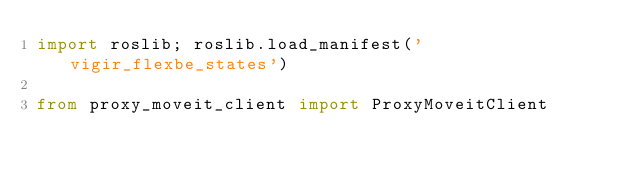Convert code to text. <code><loc_0><loc_0><loc_500><loc_500><_Python_>import roslib; roslib.load_manifest('vigir_flexbe_states')

from proxy_moveit_client import ProxyMoveitClient
</code> 